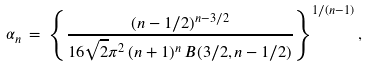<formula> <loc_0><loc_0><loc_500><loc_500>\alpha _ { n } \, = \, \left \{ \frac { ( n - 1 / 2 ) ^ { n - 3 / 2 } } { 1 6 \sqrt { 2 } \pi ^ { 2 } \, ( n + 1 ) ^ { n } \, B ( 3 / 2 , n - 1 / 2 ) } \right \} ^ { 1 / ( n - 1 ) } ,</formula> 